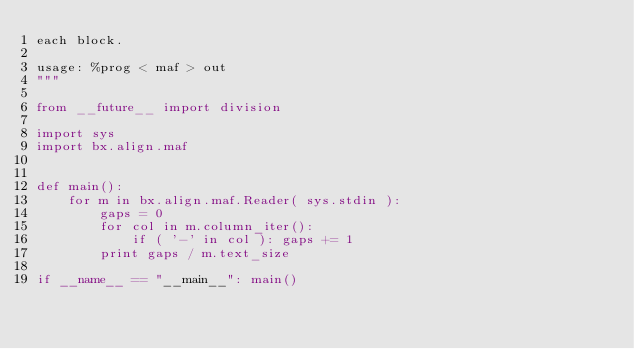Convert code to text. <code><loc_0><loc_0><loc_500><loc_500><_Python_>each block.

usage: %prog < maf > out
"""

from __future__ import division

import sys
import bx.align.maf


def main():    
    for m in bx.align.maf.Reader( sys.stdin ):  
        gaps = 0        
        for col in m.column_iter():
            if ( '-' in col ): gaps += 1          
        print gaps / m.text_size

if __name__ == "__main__": main()
</code> 